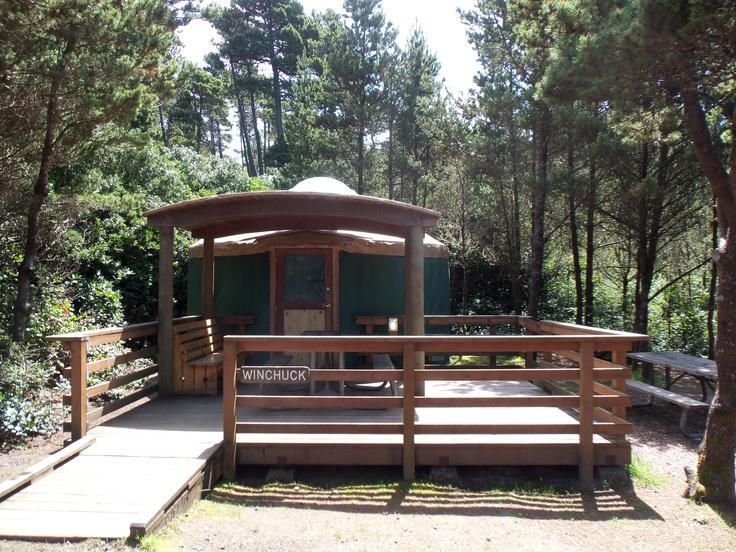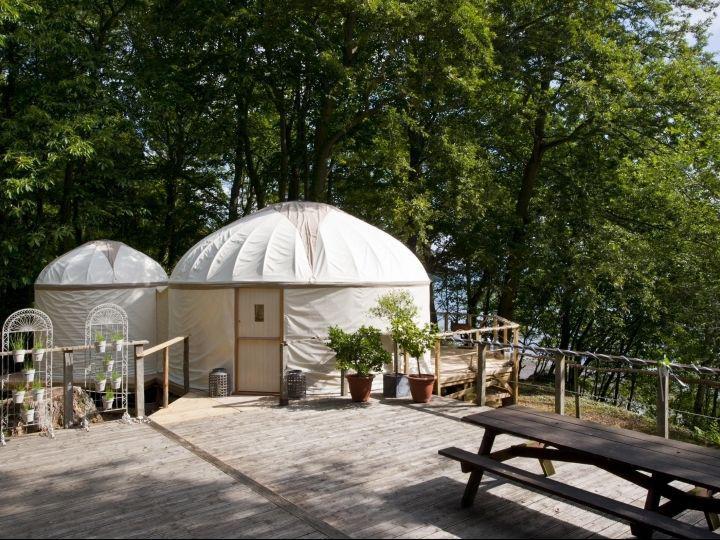The first image is the image on the left, the second image is the image on the right. Examine the images to the left and right. Is the description "An image shows side-by-side joined structures, both with cone/dome tops." accurate? Answer yes or no. Yes. The first image is the image on the left, the second image is the image on the right. For the images shown, is this caption "Two round houses are sitting in snowy areas." true? Answer yes or no. No. 